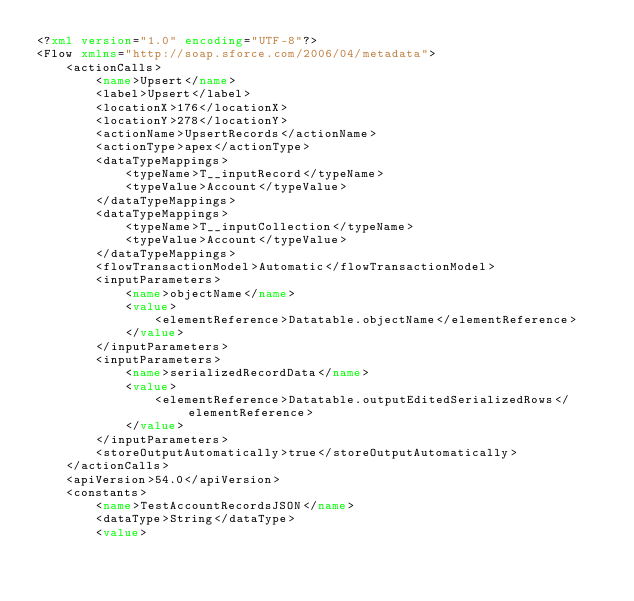<code> <loc_0><loc_0><loc_500><loc_500><_XML_><?xml version="1.0" encoding="UTF-8"?>
<Flow xmlns="http://soap.sforce.com/2006/04/metadata">
    <actionCalls>
        <name>Upsert</name>
        <label>Upsert</label>
        <locationX>176</locationX>
        <locationY>278</locationY>
        <actionName>UpsertRecords</actionName>
        <actionType>apex</actionType>
        <dataTypeMappings>
            <typeName>T__inputRecord</typeName>
            <typeValue>Account</typeValue>
        </dataTypeMappings>
        <dataTypeMappings>
            <typeName>T__inputCollection</typeName>
            <typeValue>Account</typeValue>
        </dataTypeMappings>
        <flowTransactionModel>Automatic</flowTransactionModel>
        <inputParameters>
            <name>objectName</name>
            <value>
                <elementReference>Datatable.objectName</elementReference>
            </value>
        </inputParameters>
        <inputParameters>
            <name>serializedRecordData</name>
            <value>
                <elementReference>Datatable.outputEditedSerializedRows</elementReference>
            </value>
        </inputParameters>
        <storeOutputAutomatically>true</storeOutputAutomatically>
    </actionCalls>
    <apiVersion>54.0</apiVersion>
    <constants>
        <name>TestAccountRecordsJSON</name>
        <dataType>String</dataType>
        <value></code> 